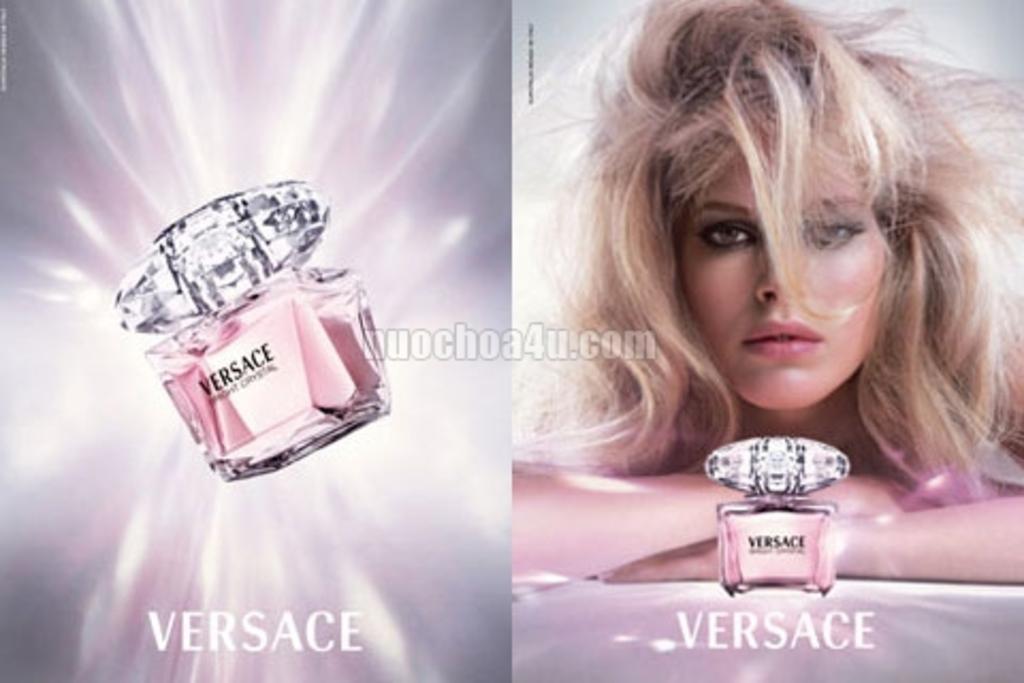What type of artwork is the image? The image is a collage. Can you describe the main subject in the image? There is a woman in the image. What other objects can be seen in the image? There are perfume bottles in the image. What is the central feature of the collage? There is a watermark in the center of the image. What text is present in the image? There are words at the bottom of the image. What is the temperature of the church in the image? There is no mention of a church or temperature in the image. 